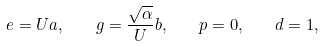<formula> <loc_0><loc_0><loc_500><loc_500>e = U a , \quad g = \frac { \sqrt { \alpha } } { U } b , \quad p = 0 , \quad d = 1 ,</formula> 